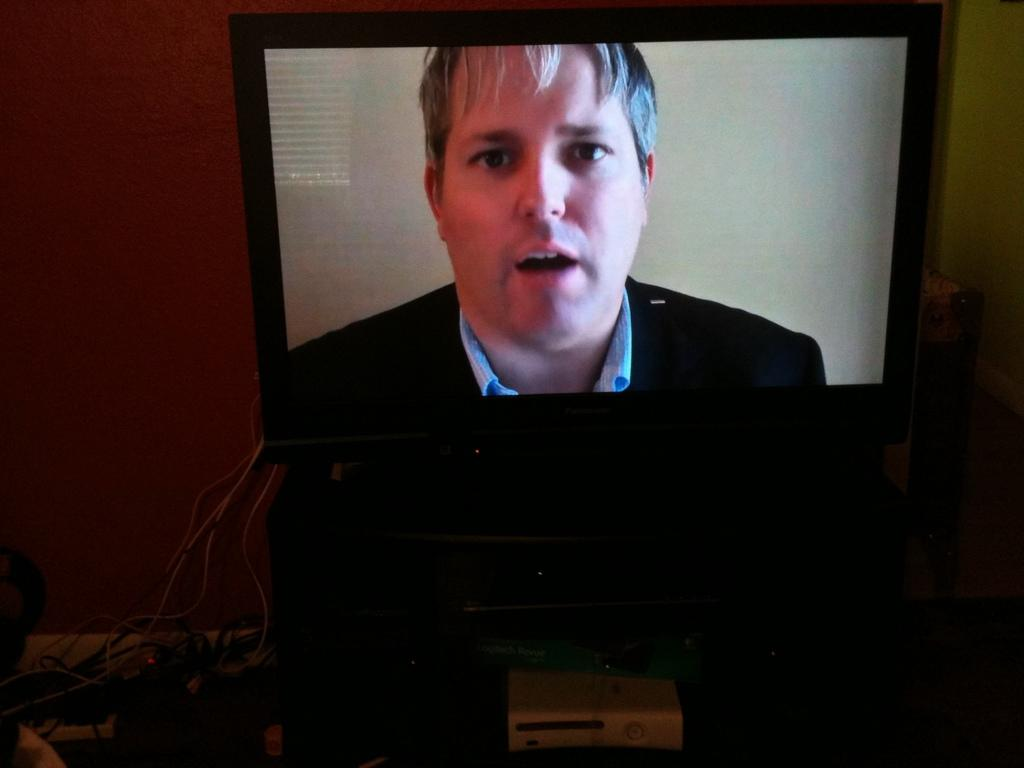What is the main object in the center of the image? There is a TV in the center of the image. Are there any connections to the TV? Yes, cables are connected to the TV. What can be seen on the screen of the TV? There is a man visible on the screen of the TV. How far away is the mint from the TV in the image? There is no mint present in the image, so it cannot be determined how far away it would be from the TV. 